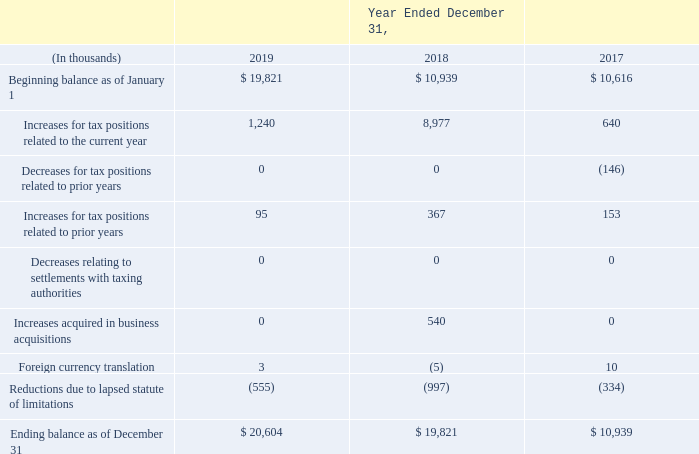Changes in the amounts of unrecognized tax benefits were as follows:
We had gross unrecognized tax benefits of $20.6 million and $19.8 million as of December 31, 2019 and 2018, respectively. If the current gross unrecognized tax benefits were recognized, the result would be an increase in our income tax benefit of $20.7 million and $19.6 million, respectively. These amounts are net of accrued interest and penalties relating to unrecognized tax benefits of $0.4 million and $0.2 million, respectively.
We believe that it is reasonably possible that $0.2 million of our currently remaining unrecognized tax benefits may be recognized by the end of 2020, as a result of a lapse of the applicable statute of limitations.
How much is the gross unrecognized tax benefits as of December 31, 2019? $20.6 million. How much is the gross unrecognized tax benefits as of December 31, 2018? $19.8 million. What would have been the impact if the current gross unrecognized tax benefits were recognized? The result would be an increase in our income tax benefit of $20.7 million and $19.6 million, respectively. What is the change in Beginning balance as of January 1 between 2019 and 2018?
Answer scale should be: thousand. 19,821-10,939
Answer: 8882. What is the change in Increases for tax positions related to the current year between 2019 and 2018?
Answer scale should be: thousand. 1,240-8,977
Answer: -7737. What is the change in Increases for tax positions related to prior years between 2019 and 2018?
Answer scale should be: thousand. 95-367
Answer: -272. 